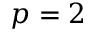Convert formula to latex. <formula><loc_0><loc_0><loc_500><loc_500>p = 2</formula> 